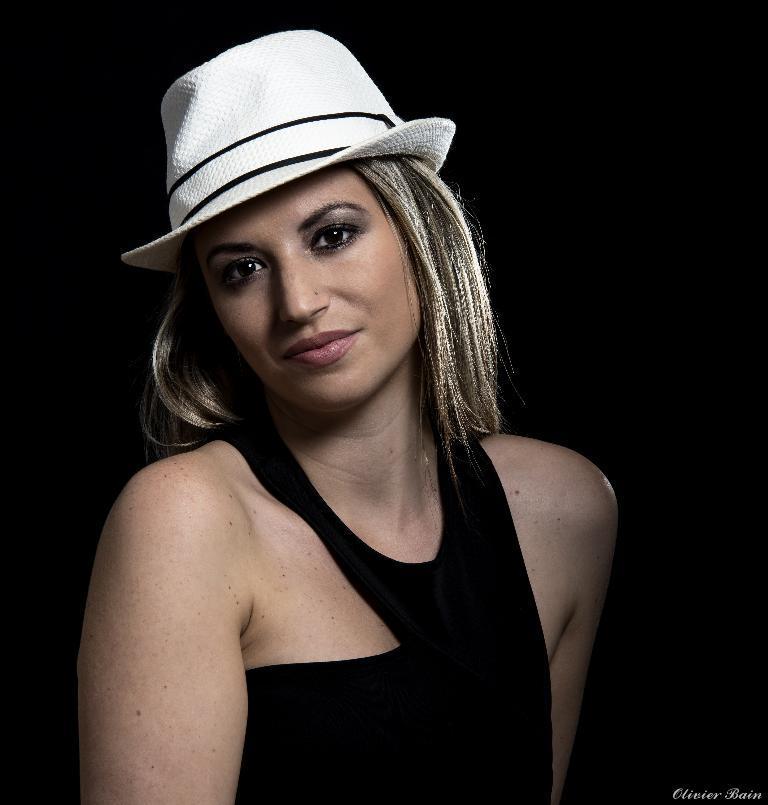How would you summarize this image in a sentence or two? In this picture there is a girl wearing black color top with white color cap on the head, smiling and giving a pose in the camera. Behind there is a black background. 